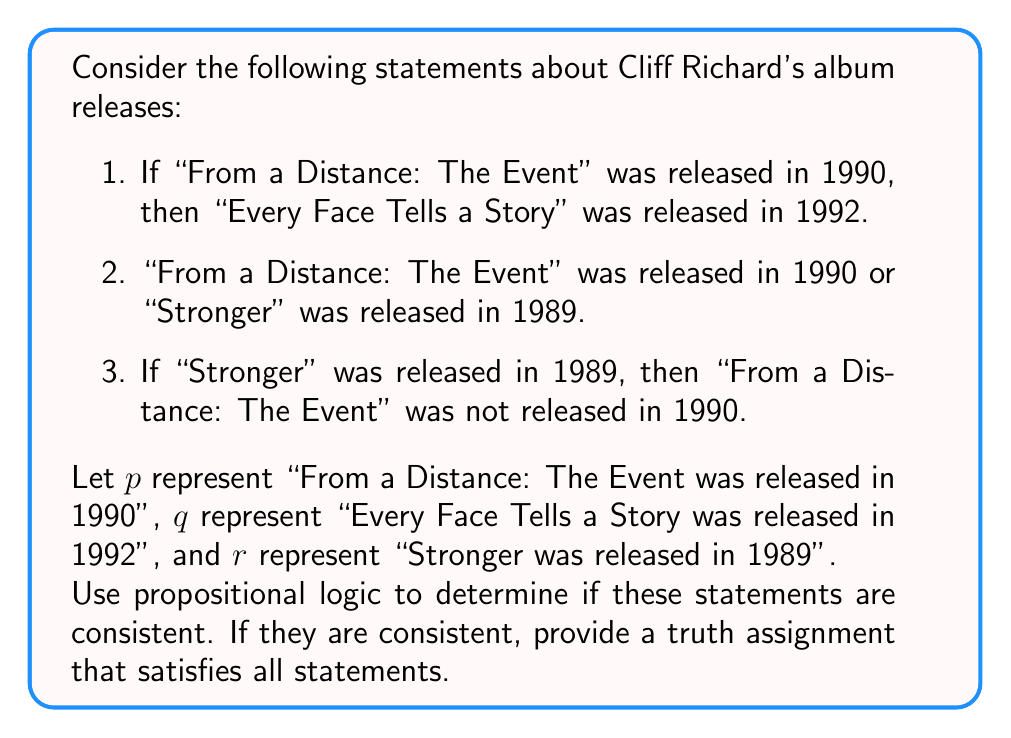Can you solve this math problem? To solve this problem, we'll use propositional logic to represent the given statements and then evaluate their consistency.

1. Translate the statements into logical propositions:
   - Statement 1: $p \rightarrow q$
   - Statement 2: $p \lor r$
   - Statement 3: $r \rightarrow \neg p$

2. Combine these statements using conjunction:
   $(p \rightarrow q) \land (p \lor r) \land (r \rightarrow \neg p)$

3. To check for consistency, we need to find a truth assignment that makes this compound statement true.

4. Let's create a truth table:

   | $p$ | $q$ | $r$ | $p \rightarrow q$ | $p \lor r$ | $r \rightarrow \neg p$ | $(p \rightarrow q) \land (p \lor r) \land (r \rightarrow \neg p)$ |
   |-----|-----|-----|-------------------|------------|------------------------|------------------------------------------------------------------|
   | T   | T   | T   | T                 | T          | F                      | F                                                                |
   | T   | T   | F   | T                 | T          | T                      | T                                                                |
   | T   | F   | T   | F                 | T          | F                      | F                                                                |
   | T   | F   | F   | F                 | T          | T                      | F                                                                |
   | F   | T   | T   | T                 | T          | T                      | T                                                                |
   | F   | T   | F   | T                 | F          | T                      | F                                                                |
   | F   | F   | T   | T                 | T          | T                      | T                                                                |
   | F   | F   | F   | T                 | F          | T                      | F                                                                |

5. From the truth table, we can see that there are two rows where the compound statement is true:
   - When $p$ is true, $q$ is true, and $r$ is false
   - When $p$ is false, $q$ is true, and $r$ is true
   - When $p$ is false, $q$ is false, and $r$ is true

6. This means the statements are consistent, as there exist truth assignments that satisfy all statements simultaneously.
Answer: The statements are consistent. One possible truth assignment that satisfies all statements is:
$p$ is true, $q$ is true, and $r$ is false.

This corresponds to:
- "From a Distance: The Event" was released in 1990
- "Every Face Tells a Story" was released in 1992
- "Stronger" was not released in 1989 